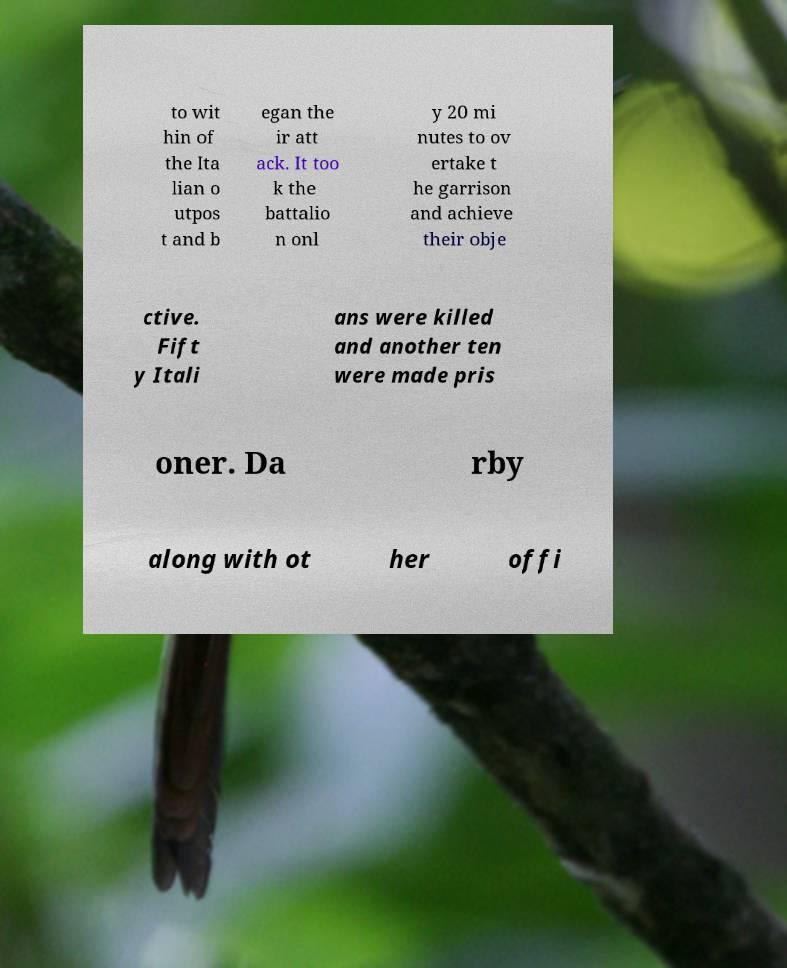I need the written content from this picture converted into text. Can you do that? to wit hin of the Ita lian o utpos t and b egan the ir att ack. It too k the battalio n onl y 20 mi nutes to ov ertake t he garrison and achieve their obje ctive. Fift y Itali ans were killed and another ten were made pris oner. Da rby along with ot her offi 